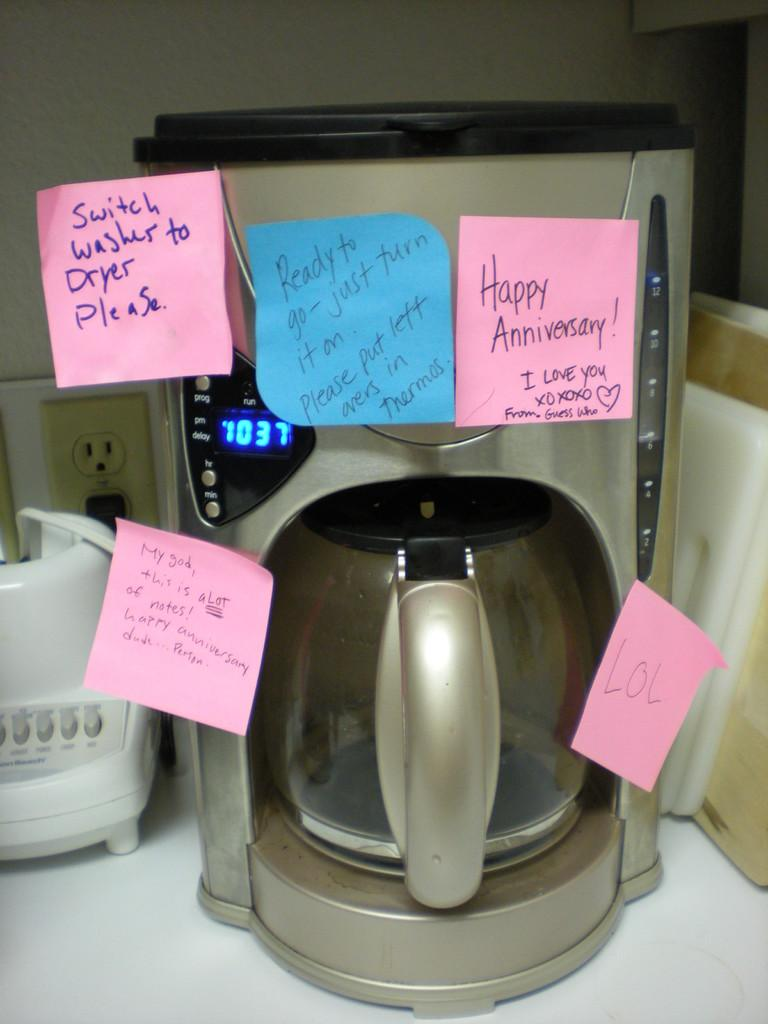<image>
Describe the image concisely. A silver coffee pot with blue and pink sticky notes on it and one says happy anniversary. 